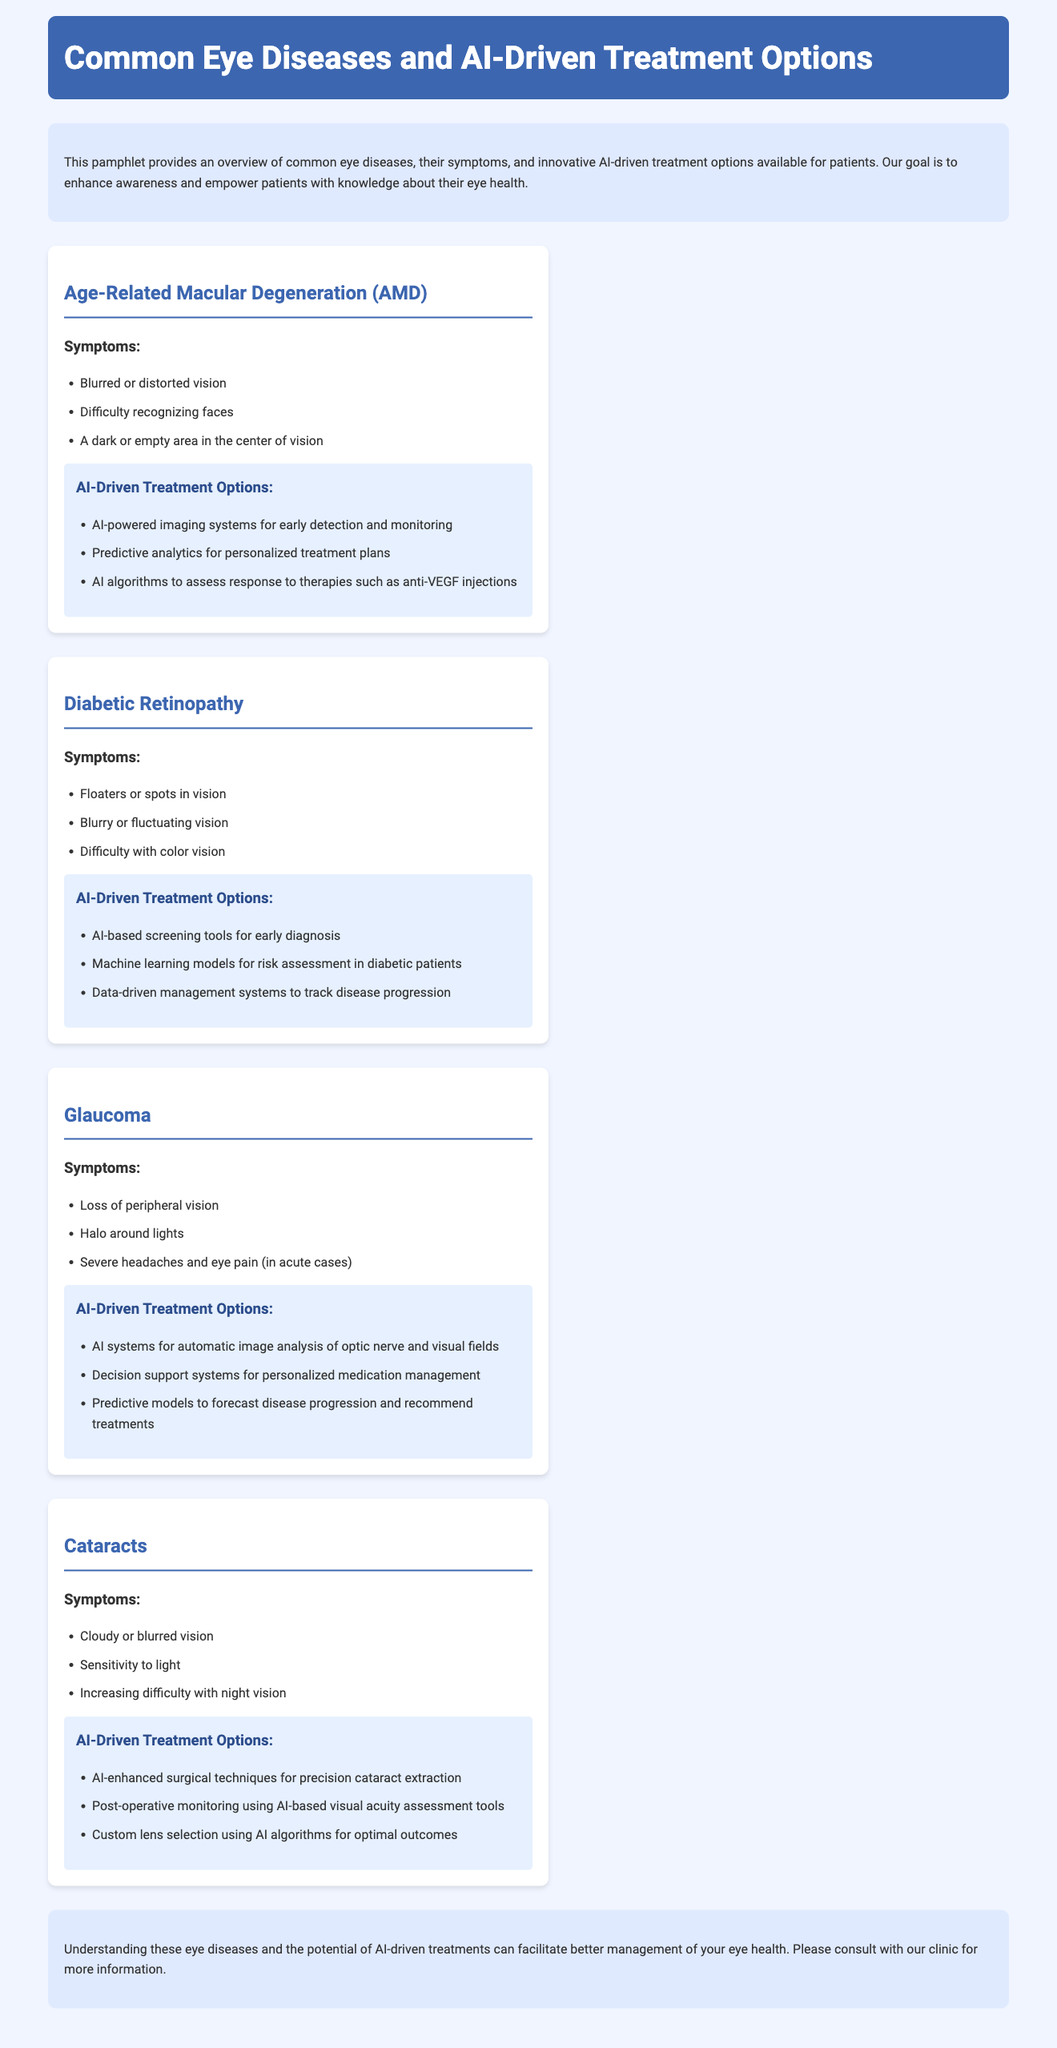What is the main purpose of the pamphlet? The pamphlet provides an overview of common eye diseases, their symptoms, and innovative AI-driven treatment options available for patients.
Answer: Overview of common eye diseases How many common eye diseases are detailed in the pamphlet? There are four common eye diseases detailed in the pamphlet: AMD, Diabetic Retinopathy, Glaucoma, and Cataracts.
Answer: Four What symptom is associated with Age-Related Macular Degeneration (AMD)? One listed symptom of AMD is blurred or distorted vision.
Answer: Blurred or distorted vision What AI-driven treatment option is mentioned for Diabetic Retinopathy? An AI-based screening tool for early diagnosis is mentioned.
Answer: AI-based screening tools Which disease includes "Loss of peripheral vision" as a symptom? Glaucoma includes "Loss of peripheral vision" as a symptom.
Answer: Glaucoma What does AI enhance in cataract treatment? AI enhances surgical techniques for precision cataract extraction.
Answer: Surgical techniques What color is used in the header background of the pamphlet? The header background color of the pamphlet is blue.
Answer: Blue What do predictive models in glaucoma aim to forecast? Predictive models in glaucoma aim to forecast disease progression.
Answer: Disease progression 